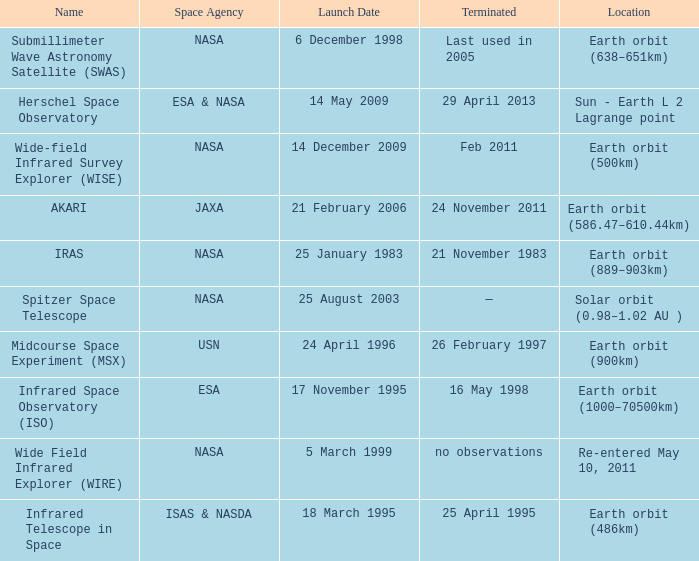When did NASA launch the wide field infrared explorer (wire)? 5 March 1999. 